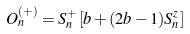<formula> <loc_0><loc_0><loc_500><loc_500>O _ { n } ^ { ( + ) } = S ^ { + } _ { n } \left [ b + ( 2 b - 1 ) S ^ { z } _ { n } \right ]</formula> 